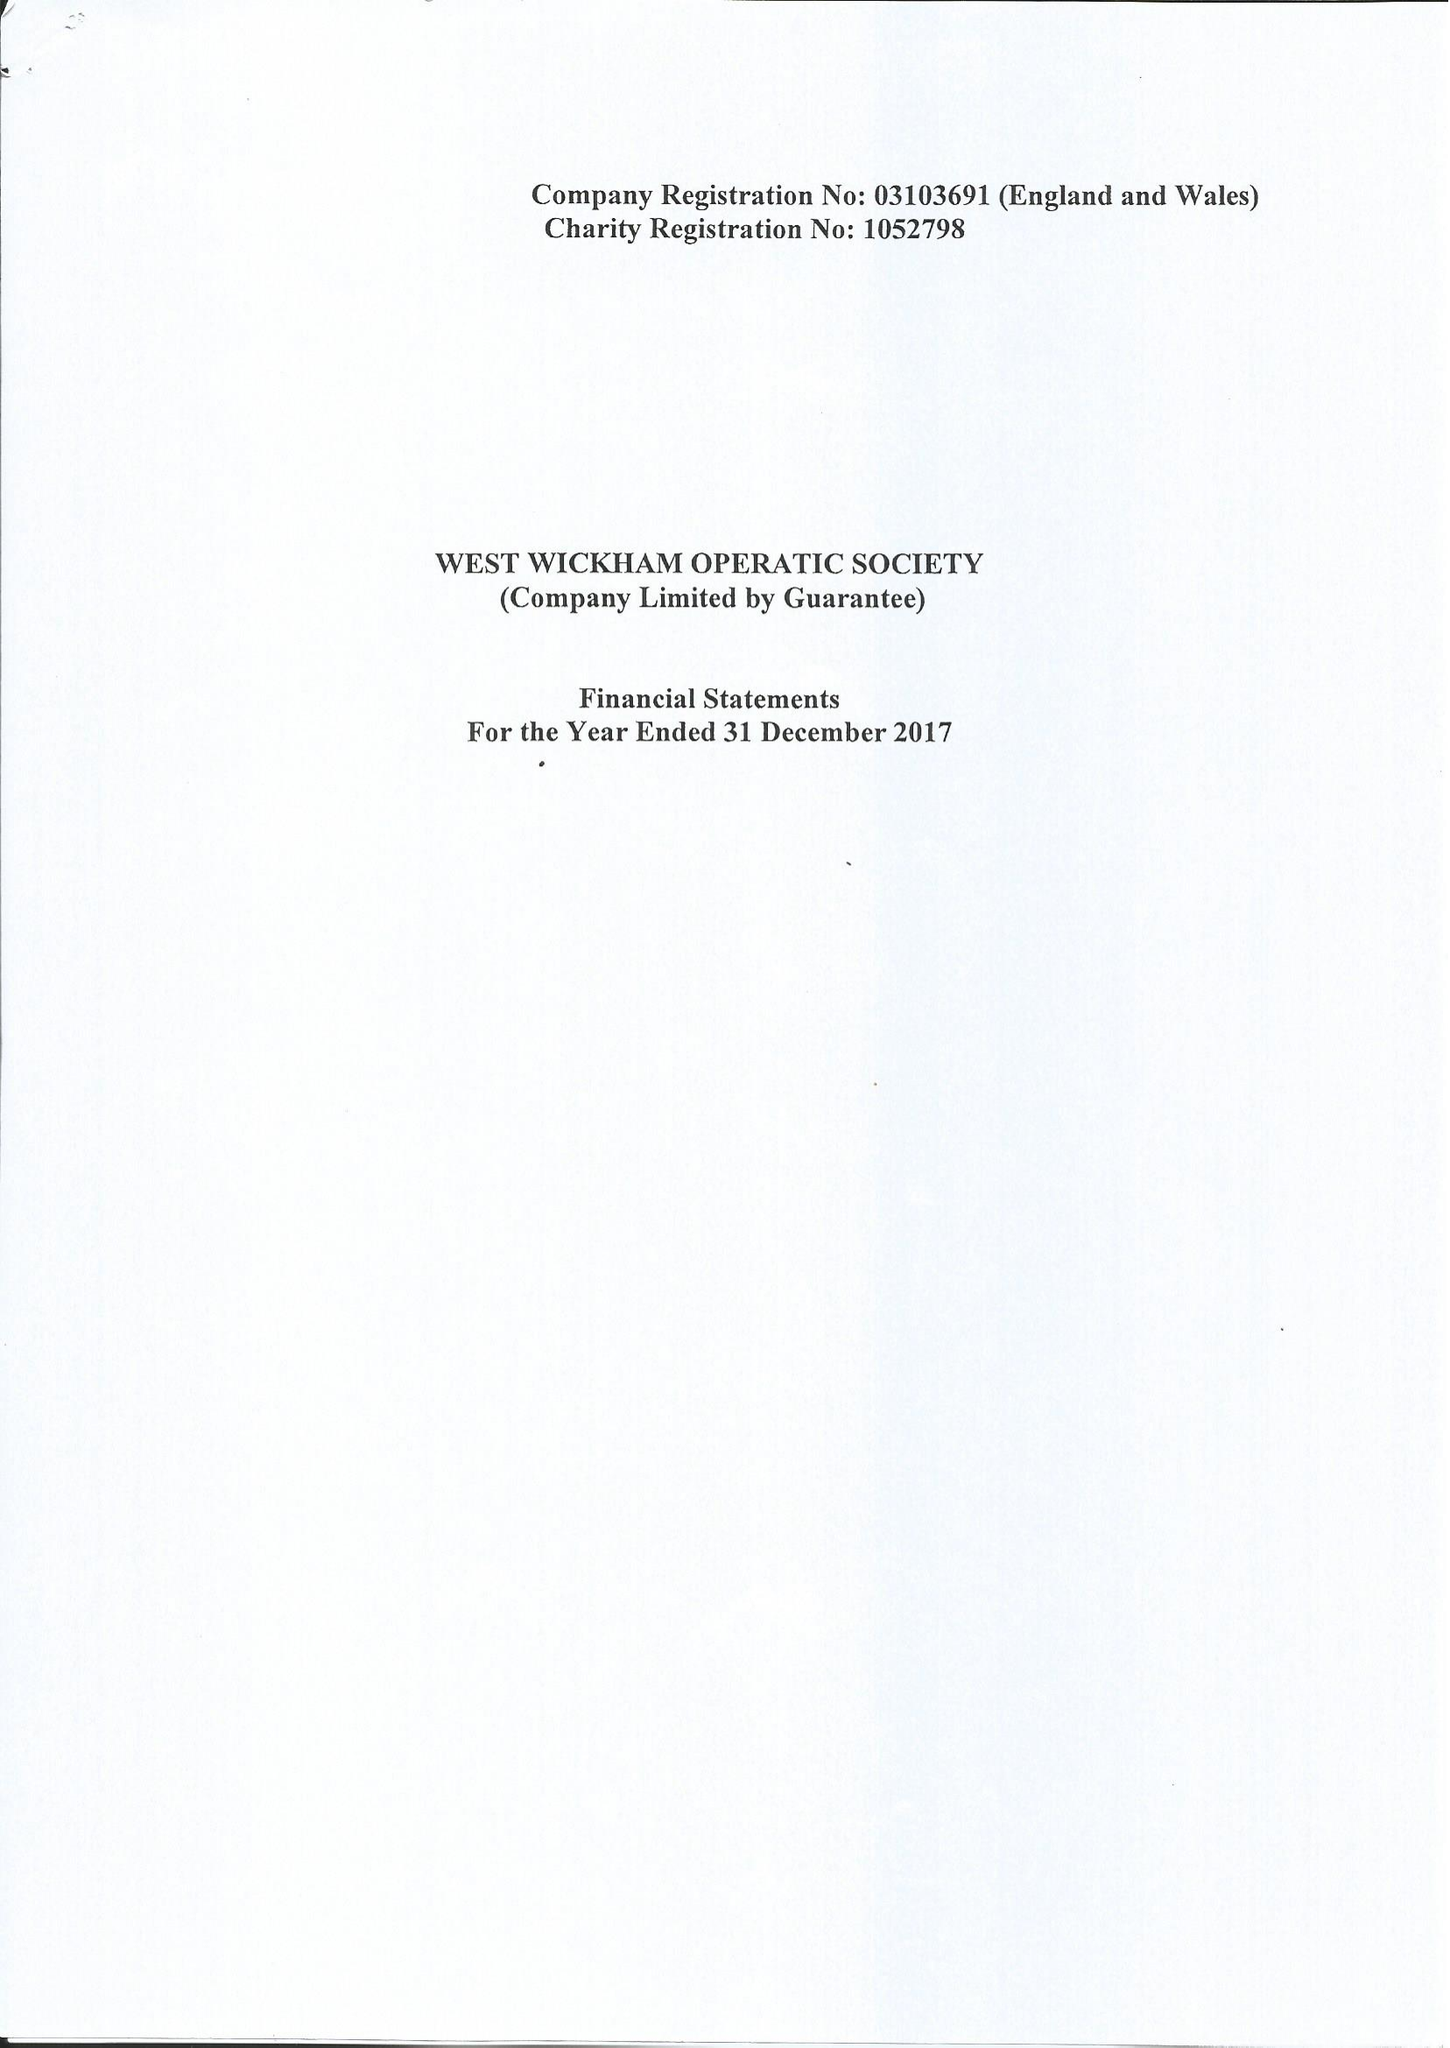What is the value for the report_date?
Answer the question using a single word or phrase. 2017-12-31 